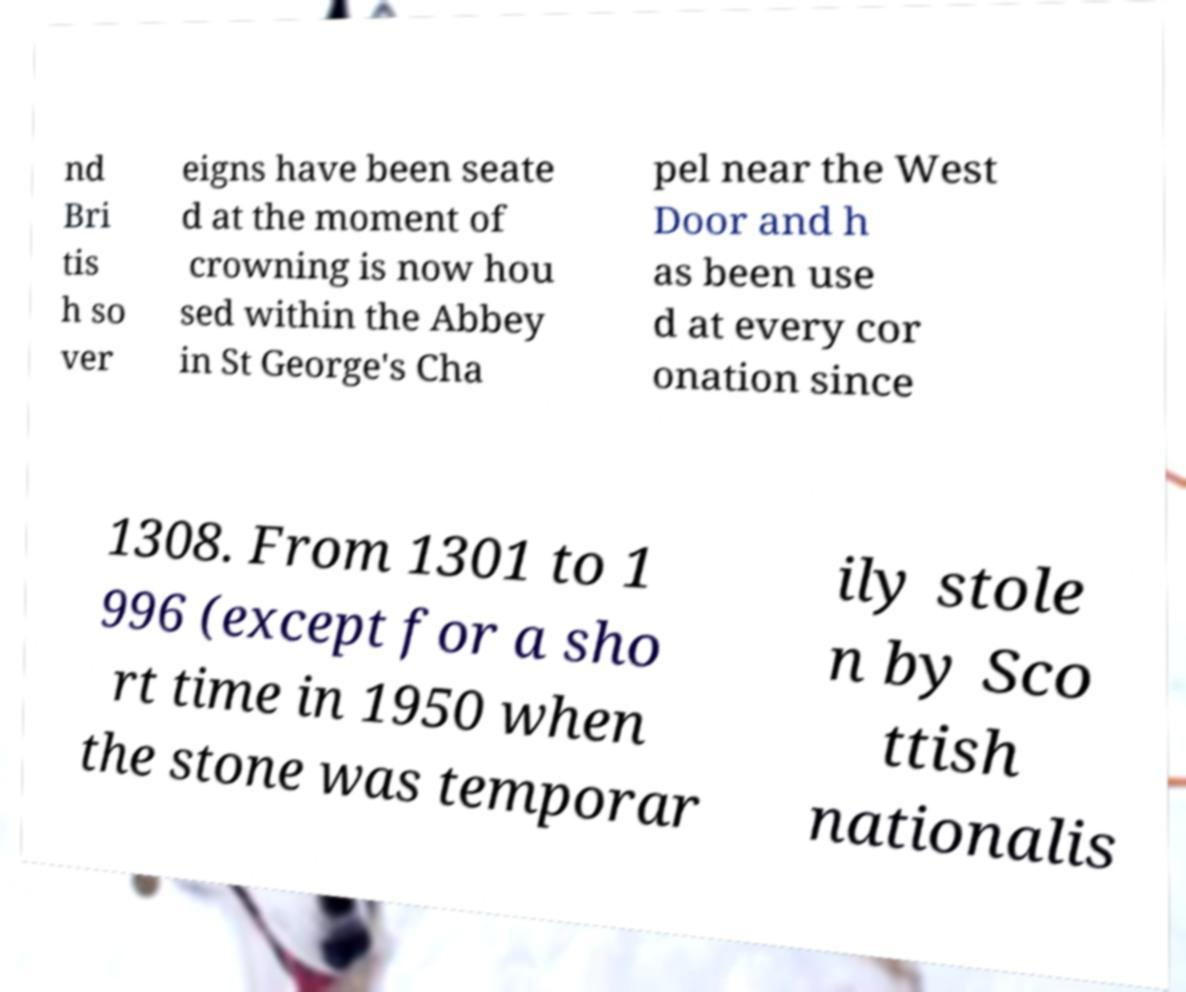I need the written content from this picture converted into text. Can you do that? nd Bri tis h so ver eigns have been seate d at the moment of crowning is now hou sed within the Abbey in St George's Cha pel near the West Door and h as been use d at every cor onation since 1308. From 1301 to 1 996 (except for a sho rt time in 1950 when the stone was temporar ily stole n by Sco ttish nationalis 